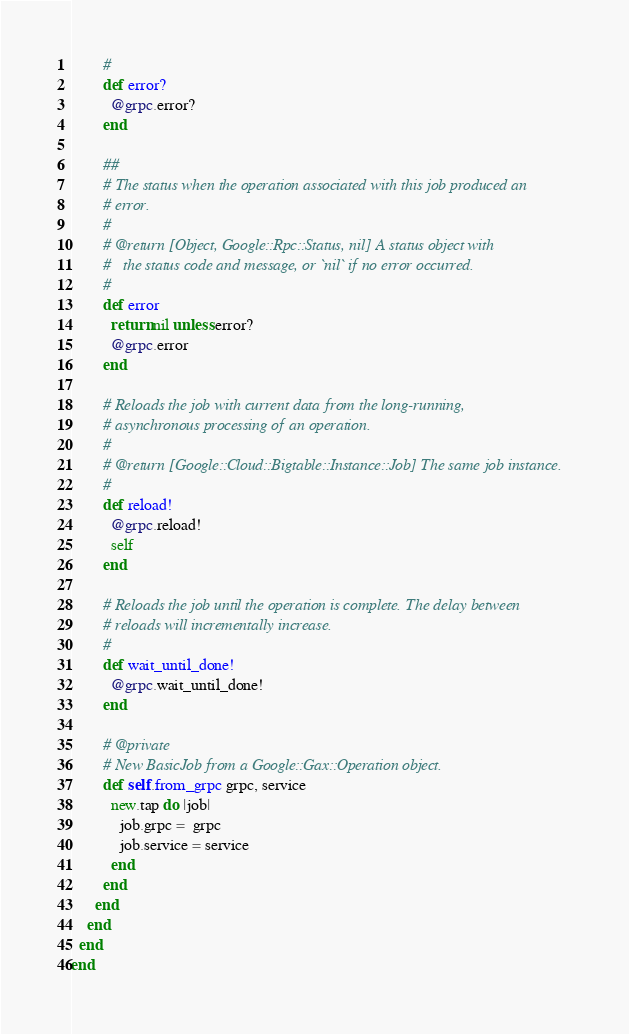<code> <loc_0><loc_0><loc_500><loc_500><_Ruby_>        #
        def error?
          @grpc.error?
        end

        ##
        # The status when the operation associated with this job produced an
        # error.
        #
        # @return [Object, Google::Rpc::Status, nil] A status object with
        #   the status code and message, or `nil` if no error occurred.
        #
        def error
          return nil unless error?
          @grpc.error
        end

        # Reloads the job with current data from the long-running,
        # asynchronous processing of an operation.
        #
        # @return [Google::Cloud::Bigtable::Instance::Job] The same job instance.
        #
        def reload!
          @grpc.reload!
          self
        end

        # Reloads the job until the operation is complete. The delay between
        # reloads will incrementally increase.
        #
        def wait_until_done!
          @grpc.wait_until_done!
        end

        # @private
        # New BasicJob from a Google::Gax::Operation object.
        def self.from_grpc grpc, service
          new.tap do |job|
            job.grpc =  grpc
            job.service = service
          end
        end
      end
    end
  end
end
</code> 